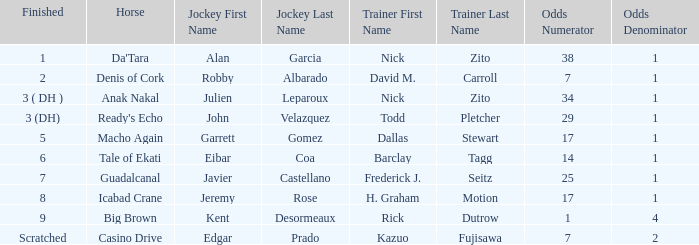What is the Finished place for da'tara trained by Nick zito? 1.0. 